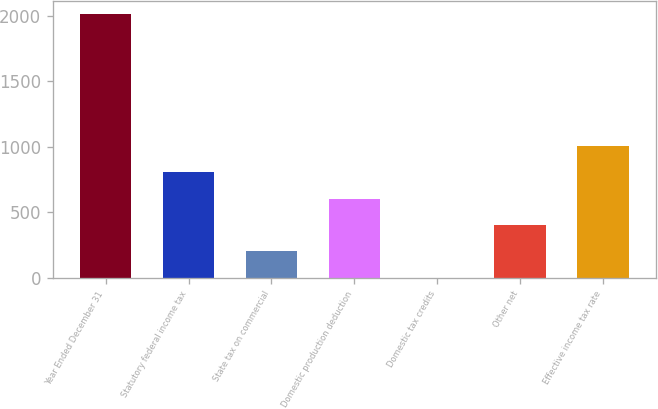Convert chart to OTSL. <chart><loc_0><loc_0><loc_500><loc_500><bar_chart><fcel>Year Ended December 31<fcel>Statutory federal income tax<fcel>State tax on commercial<fcel>Domestic production deduction<fcel>Domestic tax credits<fcel>Other net<fcel>Effective income tax rate<nl><fcel>2012<fcel>805.64<fcel>202.46<fcel>604.58<fcel>1.4<fcel>403.52<fcel>1006.7<nl></chart> 